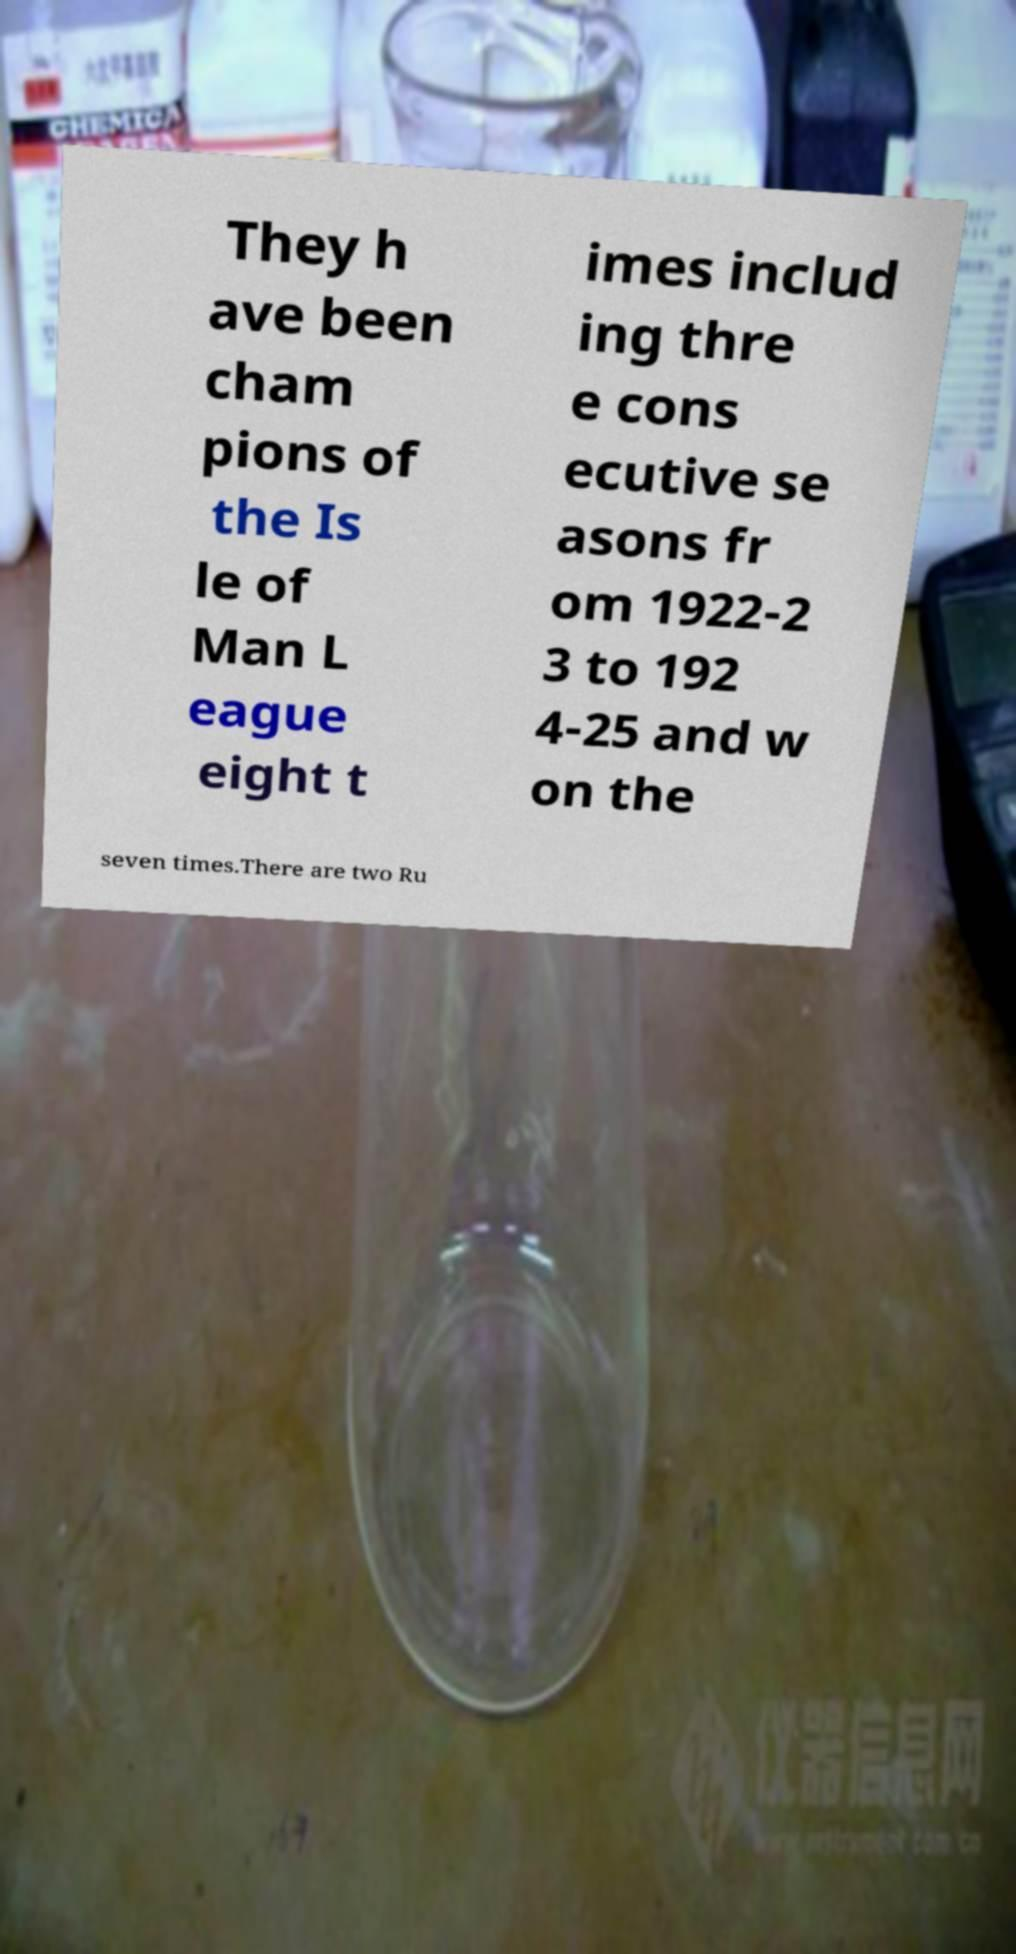Can you accurately transcribe the text from the provided image for me? They h ave been cham pions of the Is le of Man L eague eight t imes includ ing thre e cons ecutive se asons fr om 1922-2 3 to 192 4-25 and w on the seven times.There are two Ru 